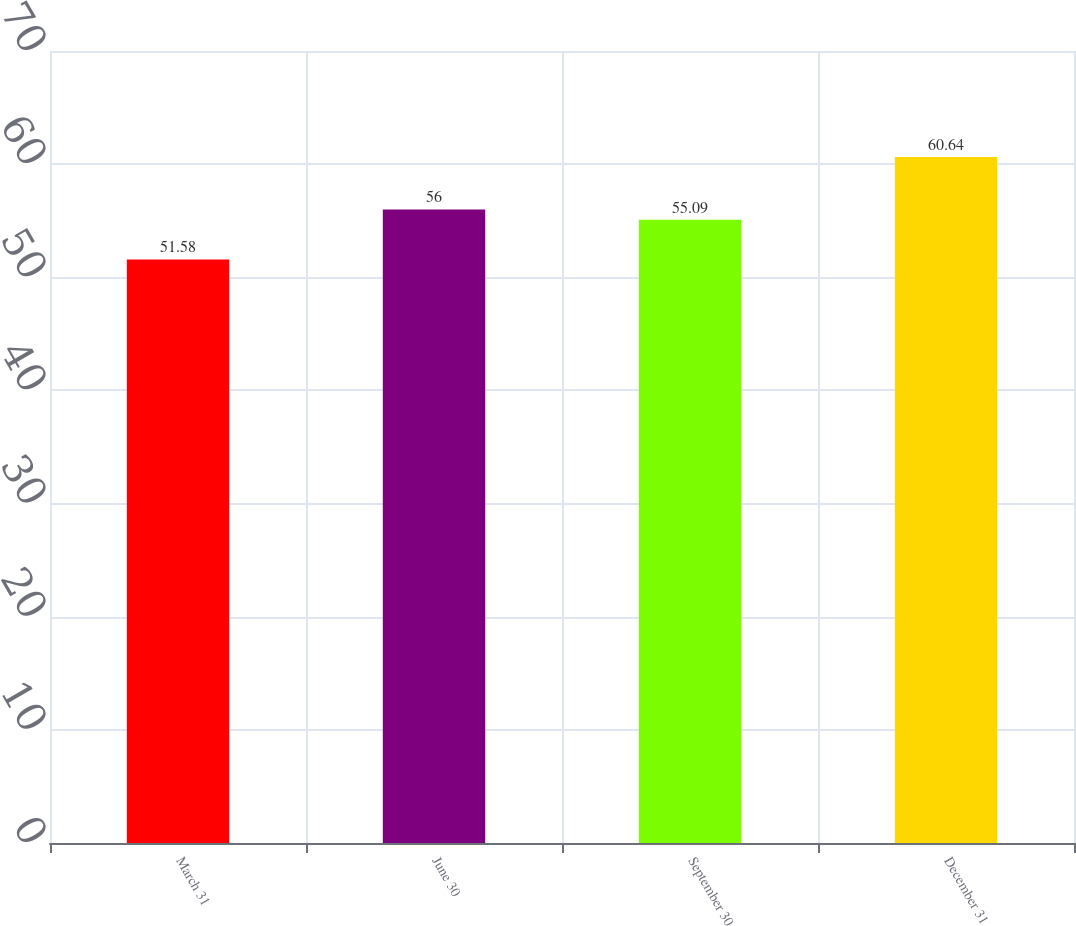Convert chart to OTSL. <chart><loc_0><loc_0><loc_500><loc_500><bar_chart><fcel>March 31<fcel>June 30<fcel>September 30<fcel>December 31<nl><fcel>51.58<fcel>56<fcel>55.09<fcel>60.64<nl></chart> 